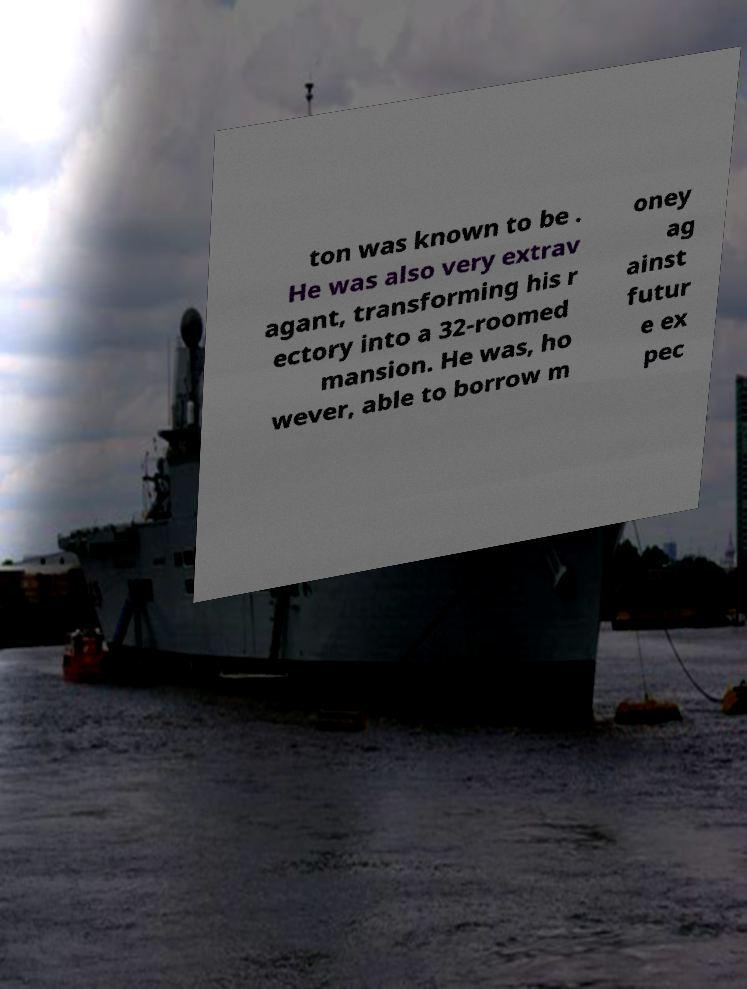For documentation purposes, I need the text within this image transcribed. Could you provide that? ton was known to be . He was also very extrav agant, transforming his r ectory into a 32-roomed mansion. He was, ho wever, able to borrow m oney ag ainst futur e ex pec 